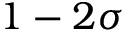<formula> <loc_0><loc_0><loc_500><loc_500>1 - 2 \sigma</formula> 